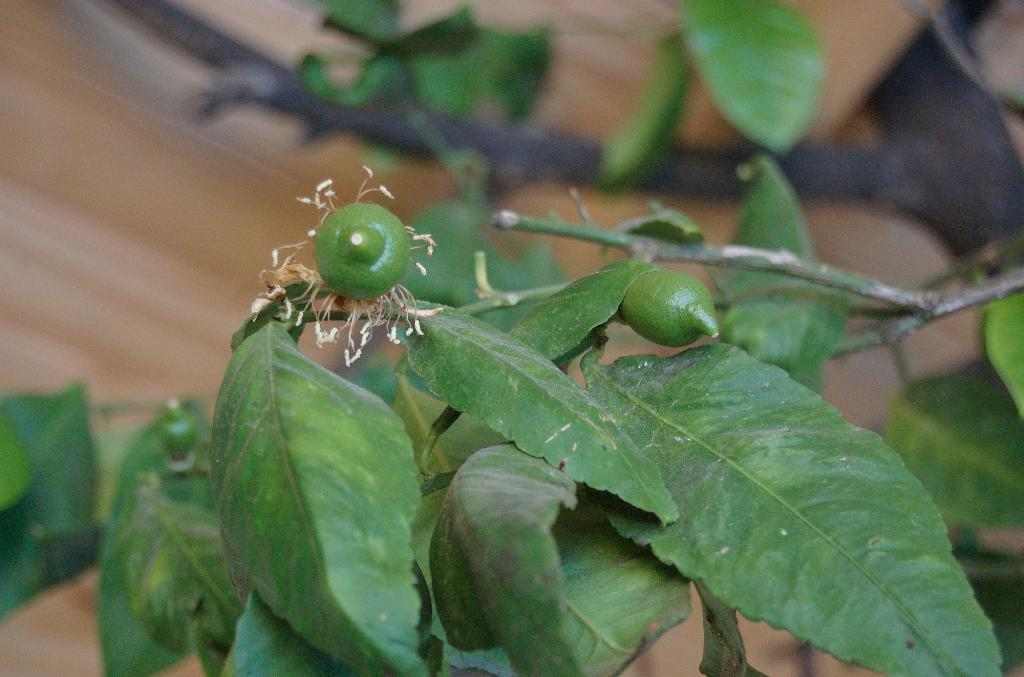What type of plant parts are visible in the image? The image contains leaves and fruits of a plant. Can you describe the background of the image? The background of the image is blurry. What type of payment is being made in the image? There is no payment being made in the image; it features leaves and fruits of a plant with a blurry background. 